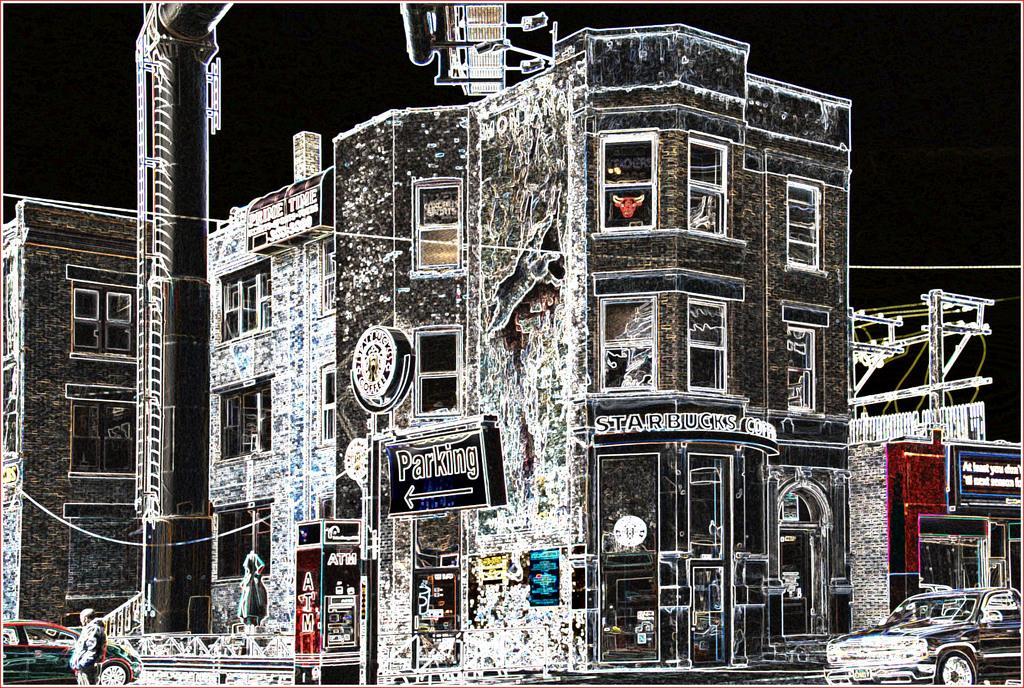Please provide a concise description of this image. It is an edited image there are some buildings and under the buildings there are stores, cafes. There is a parking board and in the foreground there are vehicles and on the left side there is a man standing beside the vehicle. 